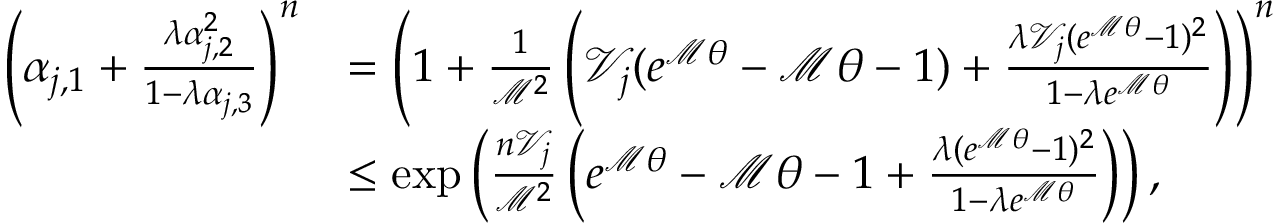Convert formula to latex. <formula><loc_0><loc_0><loc_500><loc_500>\begin{array} { r l } { \left ( \alpha _ { j , 1 } + \frac { \lambda \alpha _ { j , 2 } ^ { 2 } } { 1 - \lambda \alpha _ { j , 3 } } \right ) ^ { n } } & { = \left ( 1 + \frac { 1 } { \mathcal { M } ^ { 2 } } \left ( \mathcal { V } _ { j } ( e ^ { \mathcal { M } \theta } - \mathcal { M } \theta - 1 ) + \frac { \lambda \mathcal { V } _ { j } ( e ^ { \mathcal { M } \theta } - 1 ) ^ { 2 } } { 1 - \lambda e ^ { \mathcal { M } \theta } } \right ) \right ) ^ { n } } \\ & { \leq \exp \left ( \frac { n \mathcal { V } _ { j } } { \mathcal { M } ^ { 2 } } \left ( e ^ { \mathcal { M } \theta } - \mathcal { M } \theta - 1 + \frac { \lambda ( e ^ { \mathcal { M } \theta } - 1 ) ^ { 2 } } { 1 - \lambda e ^ { \mathcal { M } \theta } } \right ) \right ) , } \end{array}</formula> 